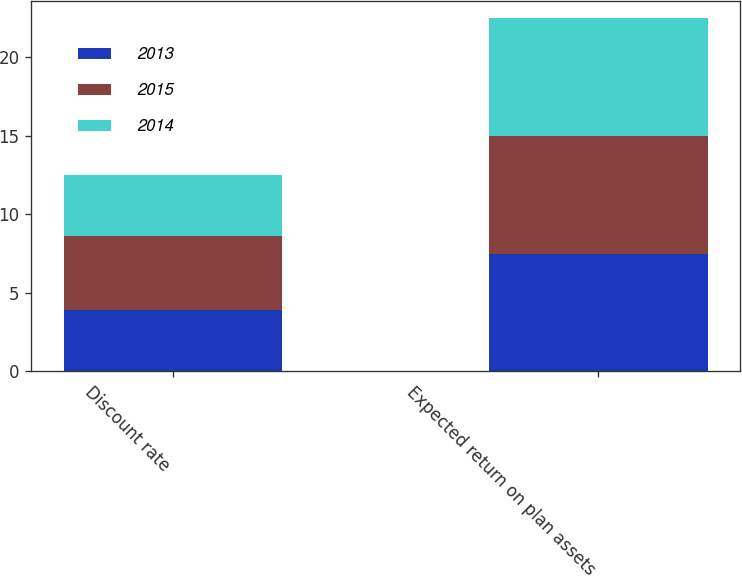<chart> <loc_0><loc_0><loc_500><loc_500><stacked_bar_chart><ecel><fcel>Discount rate<fcel>Expected return on plan assets<nl><fcel>2013<fcel>3.9<fcel>7.5<nl><fcel>2015<fcel>4.7<fcel>7.5<nl><fcel>2014<fcel>3.9<fcel>7.5<nl></chart> 